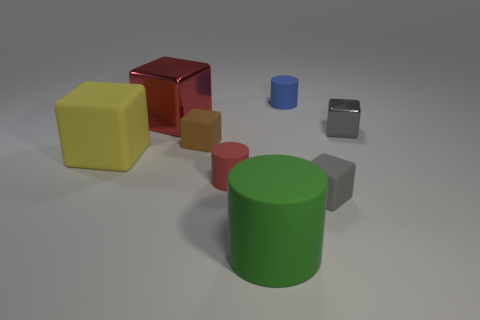How many objects are brown matte objects or small objects in front of the yellow object?
Give a very brief answer. 3. Are there fewer large metal blocks than small spheres?
Give a very brief answer. No. There is a tiny cube that is in front of the large matte thing on the left side of the brown rubber block; what is its color?
Offer a terse response. Gray. There is a red thing that is the same shape as the blue thing; what is it made of?
Give a very brief answer. Rubber. What number of matte things are either blue cylinders or gray cubes?
Provide a succinct answer. 2. Are the tiny cylinder behind the yellow thing and the gray cube that is to the right of the small gray rubber thing made of the same material?
Your response must be concise. No. Are any rubber balls visible?
Your answer should be very brief. No. Does the tiny thing that is on the left side of the tiny red object have the same shape as the matte thing that is to the right of the blue cylinder?
Ensure brevity in your answer.  Yes. Are there any tiny objects that have the same material as the brown block?
Offer a terse response. Yes. Does the small gray block behind the tiny brown matte cube have the same material as the red cylinder?
Offer a very short reply. No. 